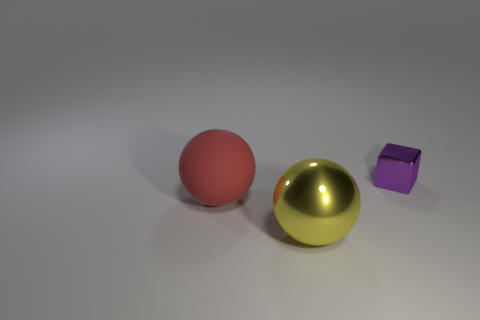Add 3 large blue matte cylinders. How many objects exist? 6 Subtract all spheres. How many objects are left? 1 Subtract 0 blue spheres. How many objects are left? 3 Subtract all big purple cylinders. Subtract all small metallic blocks. How many objects are left? 2 Add 1 big red things. How many big red things are left? 2 Add 3 red rubber objects. How many red rubber objects exist? 4 